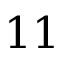Convert formula to latex. <formula><loc_0><loc_0><loc_500><loc_500>1 1</formula> 